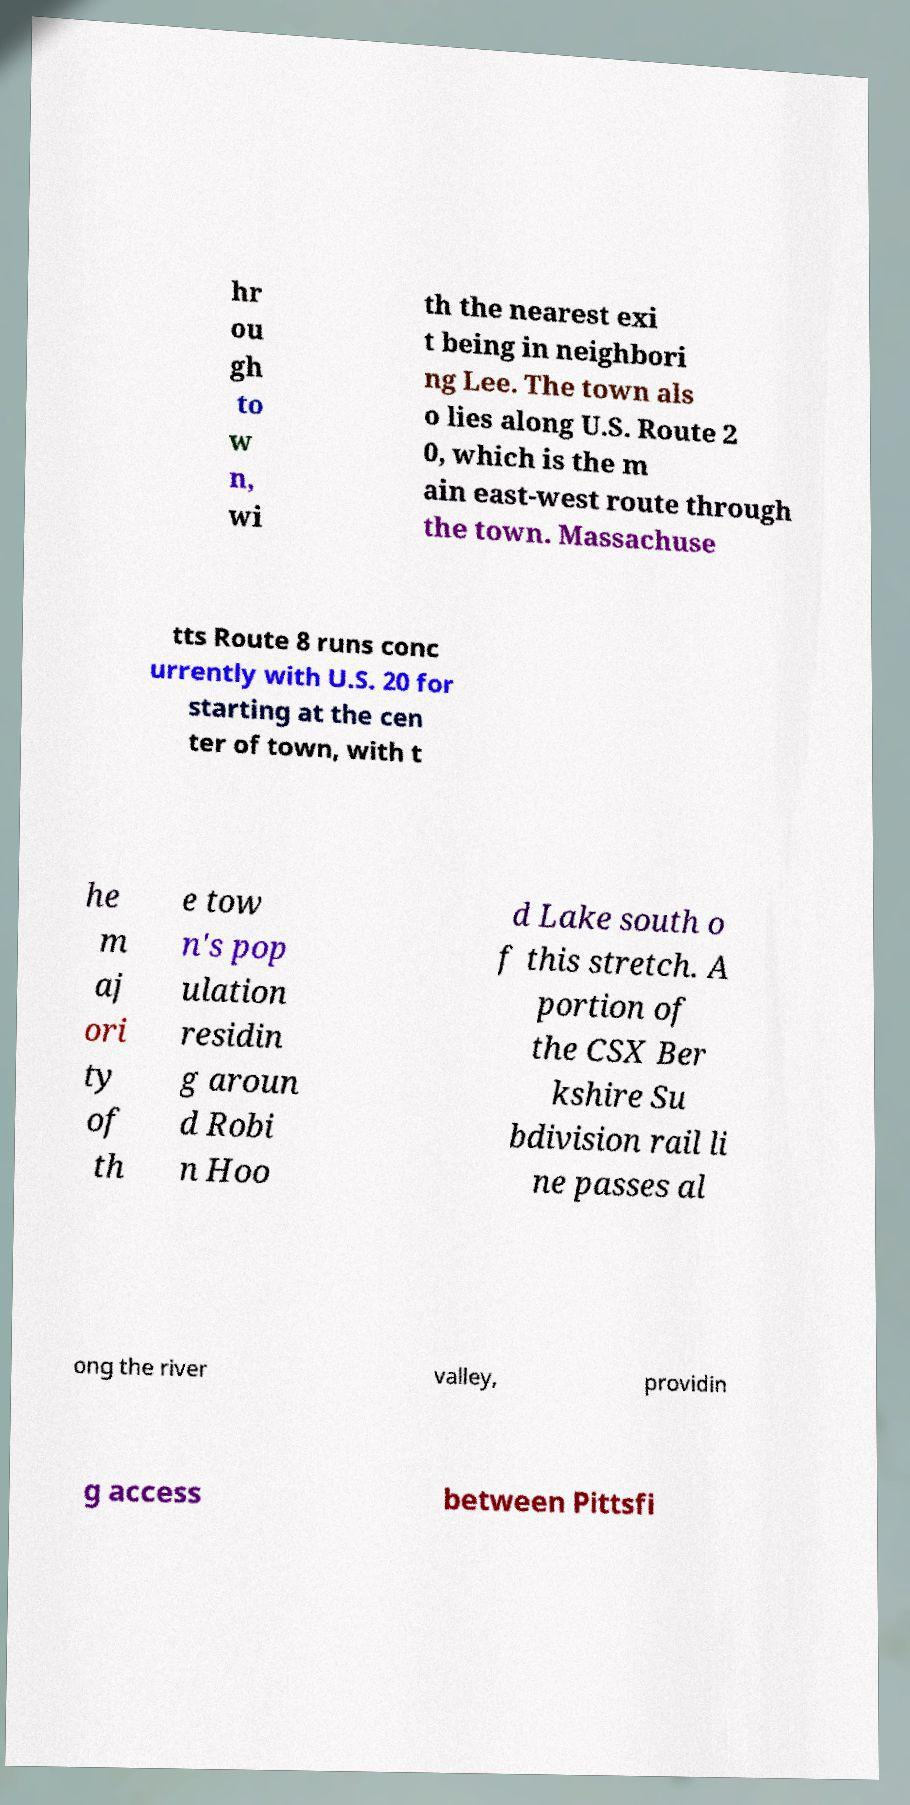I need the written content from this picture converted into text. Can you do that? hr ou gh to w n, wi th the nearest exi t being in neighbori ng Lee. The town als o lies along U.S. Route 2 0, which is the m ain east-west route through the town. Massachuse tts Route 8 runs conc urrently with U.S. 20 for starting at the cen ter of town, with t he m aj ori ty of th e tow n's pop ulation residin g aroun d Robi n Hoo d Lake south o f this stretch. A portion of the CSX Ber kshire Su bdivision rail li ne passes al ong the river valley, providin g access between Pittsfi 